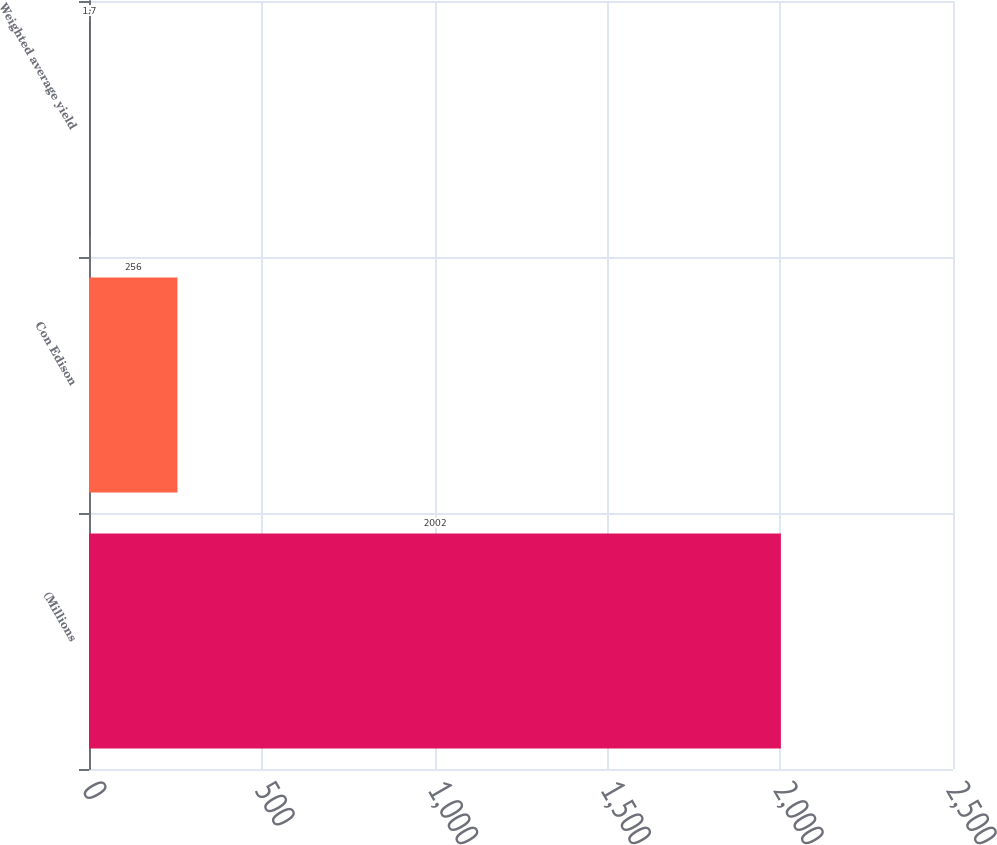<chart> <loc_0><loc_0><loc_500><loc_500><bar_chart><fcel>(Millions<fcel>Con Edison<fcel>Weighted average yield<nl><fcel>2002<fcel>256<fcel>1.7<nl></chart> 